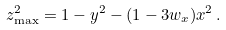<formula> <loc_0><loc_0><loc_500><loc_500>z ^ { 2 } _ { \max } = 1 - y ^ { 2 } - ( 1 - 3 w _ { x } ) x ^ { 2 } \, .</formula> 